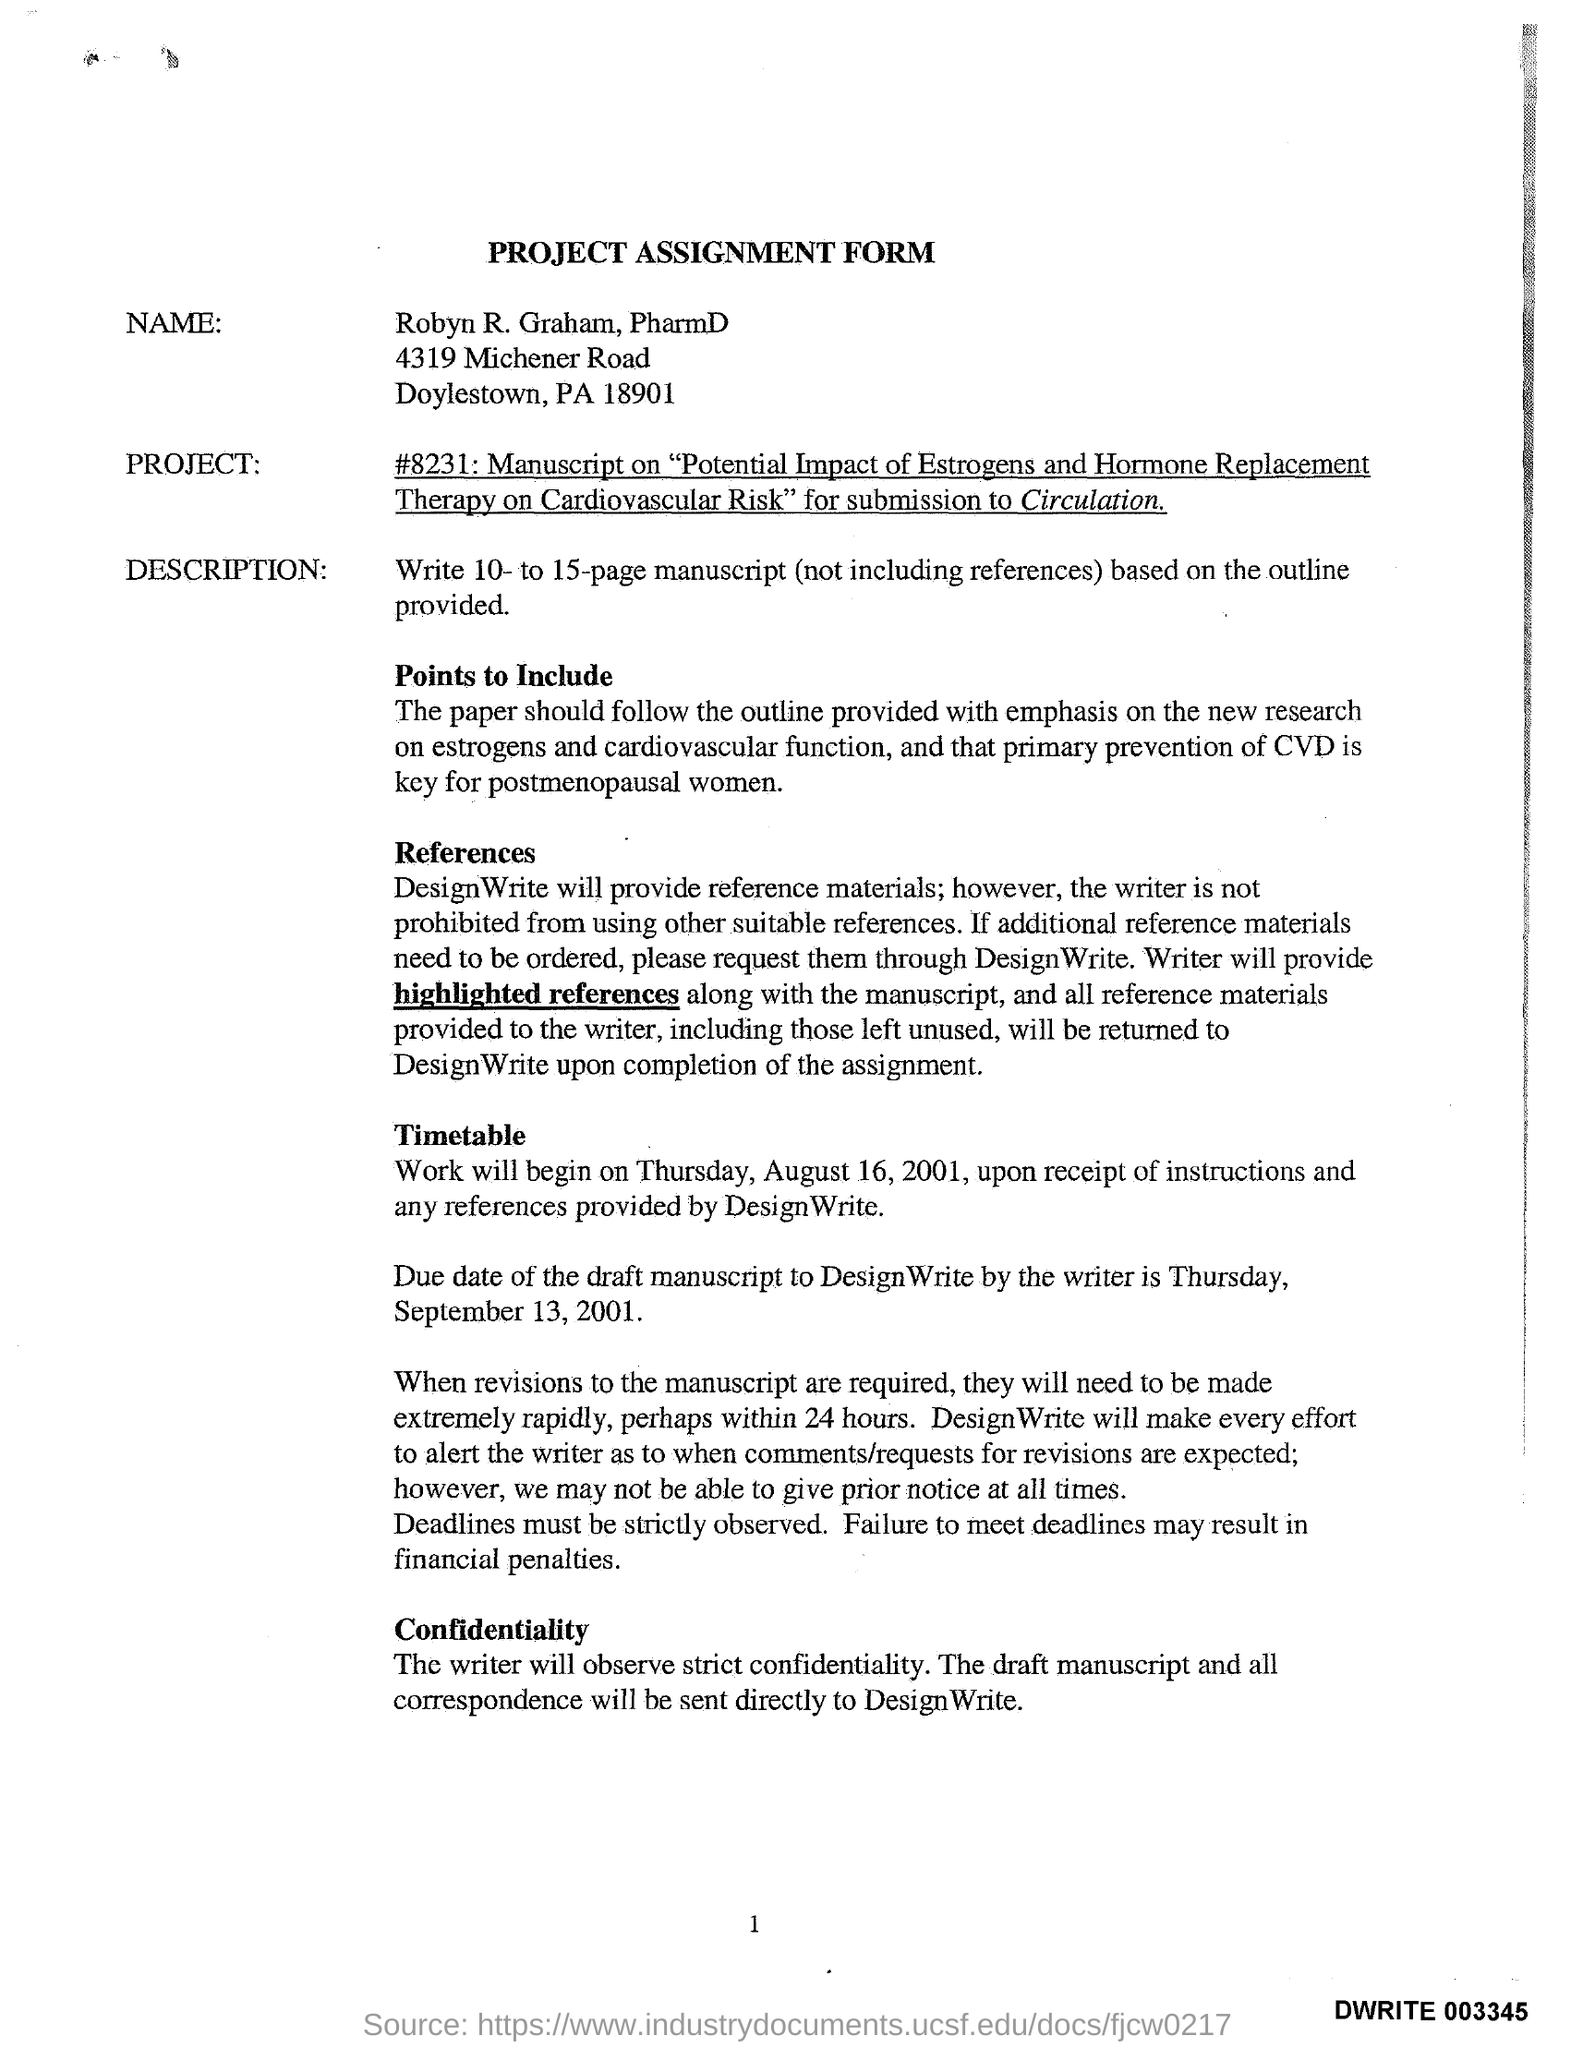What is the time duration for revisions of manuscripts ?
Offer a terse response. 24 hours. What day was August 16, 2001?
Offer a very short reply. Thursday. Due date of draft manuscript?
Ensure brevity in your answer.  Thursday, september 13, 2001. 